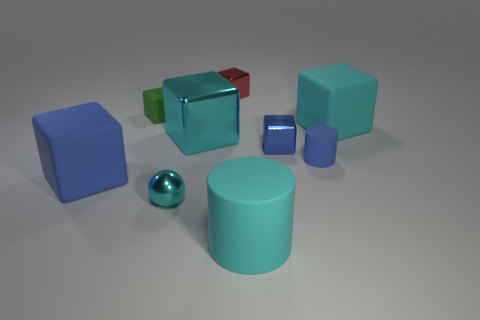There is a small thing that is the same color as the large metallic block; what shape is it?
Make the answer very short. Sphere. Does the small red thing have the same material as the large cyan cylinder right of the large metal block?
Offer a very short reply. No. There is a metallic thing that is on the left side of the cyan shiny thing that is right of the cyan ball; how big is it?
Give a very brief answer. Small. Are there any other things of the same color as the tiny rubber cube?
Your answer should be compact. No. Does the tiny cylinder on the right side of the tiny green block have the same material as the blue cube that is on the right side of the green thing?
Your answer should be compact. No. What material is the cyan thing that is both on the left side of the large cyan cylinder and behind the small cyan metallic thing?
Give a very brief answer. Metal. There is a big blue object; is its shape the same as the tiny blue object that is behind the small blue matte thing?
Make the answer very short. Yes. What is the cyan block that is left of the tiny blue object that is behind the small cylinder that is right of the tiny red cube made of?
Your response must be concise. Metal. How many other objects are there of the same size as the cyan shiny ball?
Your answer should be very brief. 4. Does the ball have the same color as the large cylinder?
Keep it short and to the point. Yes. 